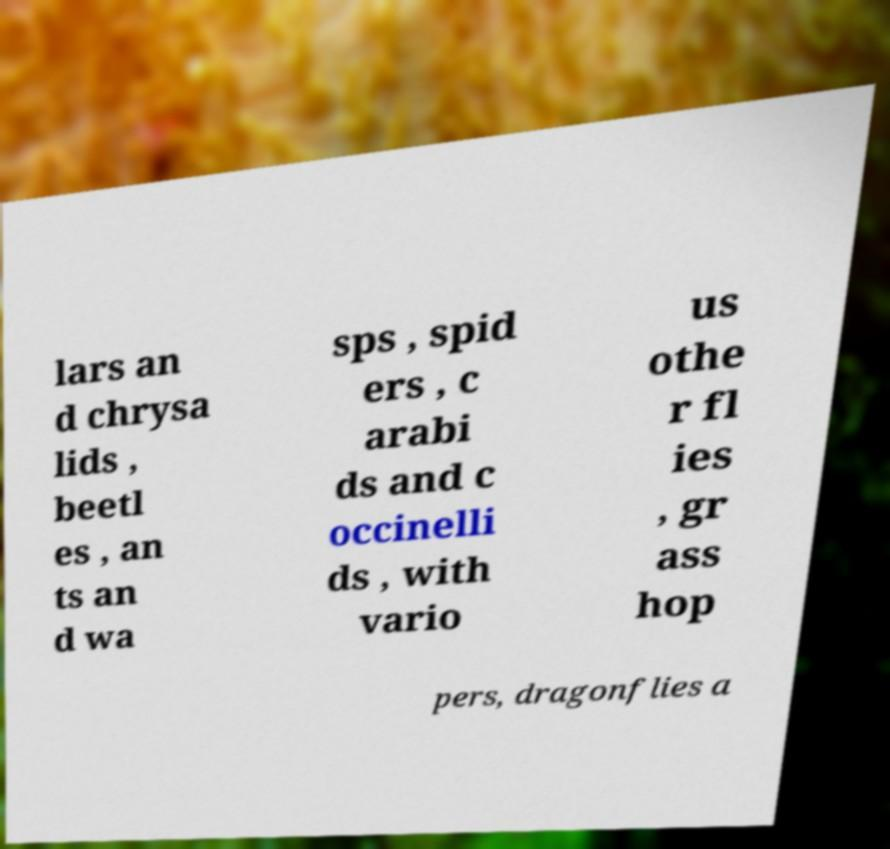I need the written content from this picture converted into text. Can you do that? lars an d chrysa lids , beetl es , an ts an d wa sps , spid ers , c arabi ds and c occinelli ds , with vario us othe r fl ies , gr ass hop pers, dragonflies a 